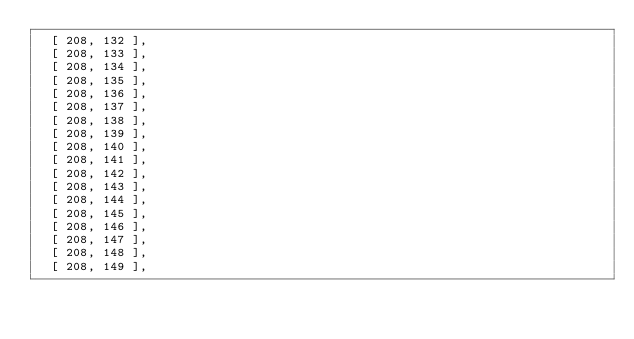<code> <loc_0><loc_0><loc_500><loc_500><_Python_>  [ 208, 132 ],
  [ 208, 133 ],
  [ 208, 134 ],
  [ 208, 135 ],
  [ 208, 136 ],
  [ 208, 137 ],
  [ 208, 138 ],
  [ 208, 139 ],
  [ 208, 140 ],
  [ 208, 141 ],
  [ 208, 142 ],
  [ 208, 143 ],
  [ 208, 144 ],
  [ 208, 145 ],
  [ 208, 146 ],
  [ 208, 147 ],
  [ 208, 148 ],
  [ 208, 149 ],</code> 